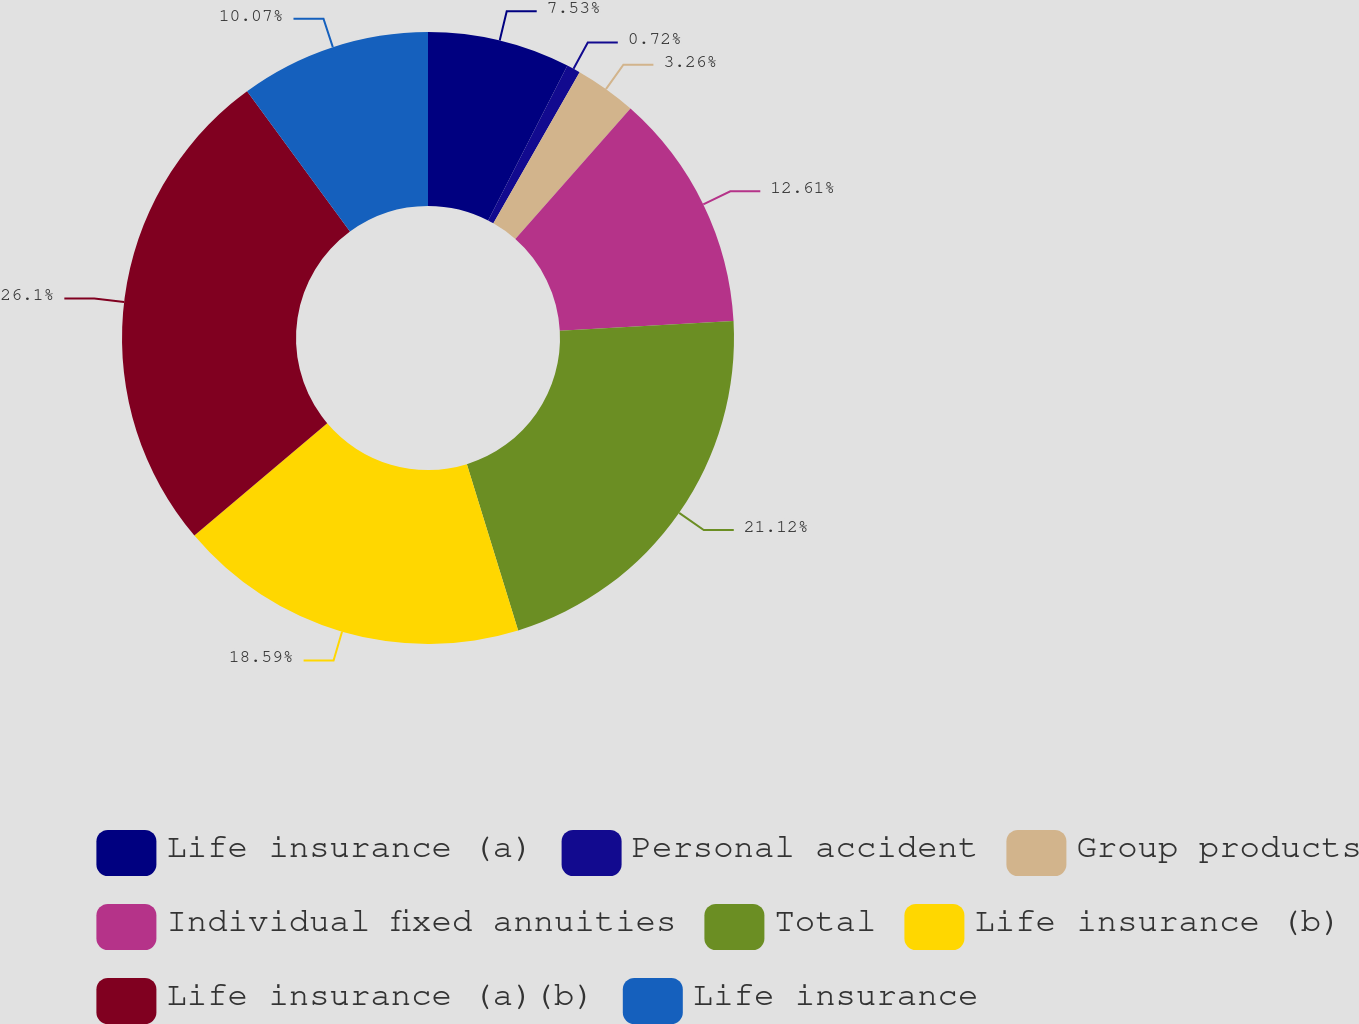<chart> <loc_0><loc_0><loc_500><loc_500><pie_chart><fcel>Life insurance (a)<fcel>Personal accident<fcel>Group products<fcel>Individual fixed annuities<fcel>Total<fcel>Life insurance (b)<fcel>Life insurance (a)(b)<fcel>Life insurance<nl><fcel>7.53%<fcel>0.72%<fcel>3.26%<fcel>12.61%<fcel>21.13%<fcel>18.59%<fcel>26.11%<fcel>10.07%<nl></chart> 